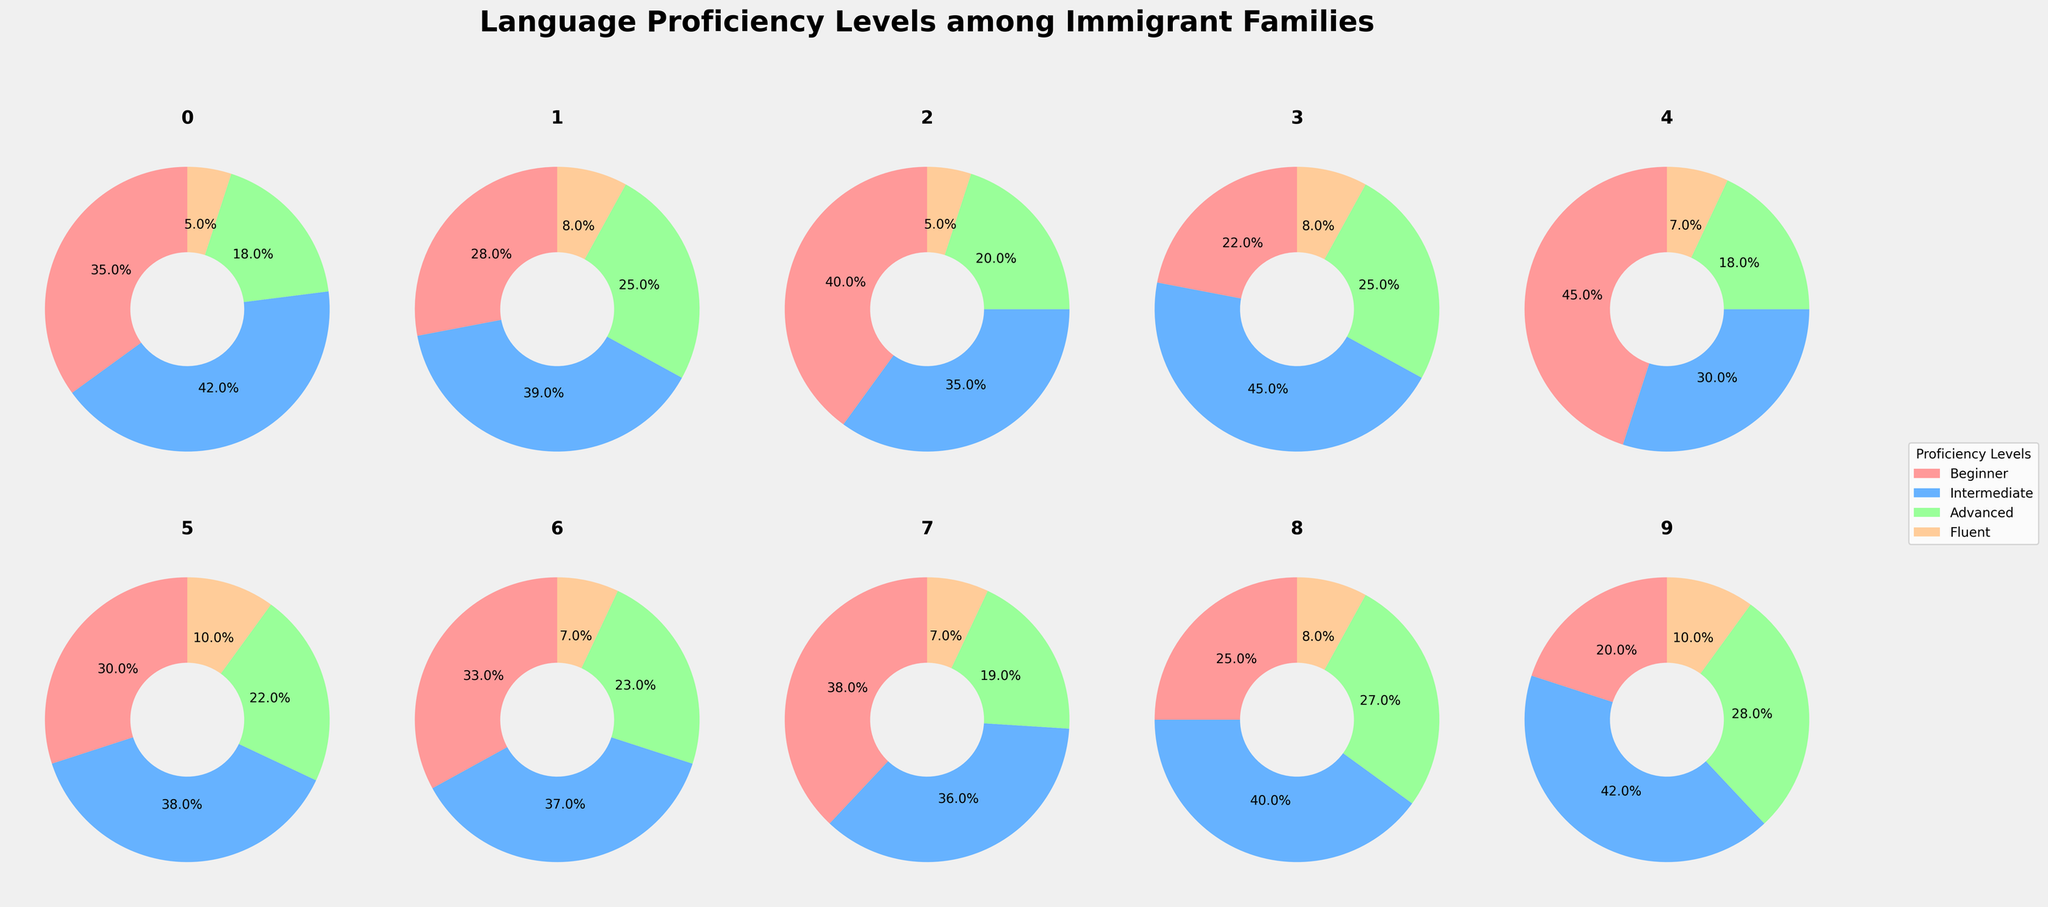Which native language has the highest proportion of Beginner proficiency levels? Looking at the slices labeled 'Beginner' in each pie chart, we can see that the Arabic language has the largest slice for Beginner proficiency.
Answer: Arabic What is the combined percentage of Fluent proficiency for Chinese, Russian, and Vietnamese? Adding the Fluent percentages directly from each language's chart: Chinese (8%) + Russian (8%) + Vietnamese (5%) gives us a total.
Answer: 21% Which language shows a more even distribution across all proficiency levels? By examining the pie charts, Portuguese and Tagalog show relatively balanced distributions across all proficiency levels. However, Portuguese has no overly dominant segment.
Answer: Portuguese How does the number of Intermediate proficiency levels compare between Spanish and Polish? From the pie charts, Spanish has 30% Intermediate, and Polish has 31% Intermediate, so Polish has a marginally higher proportion.
Answer: Polish Which language has the lowest proportion of Fluent speakers? Comparing the 'Fluent' slices of each pie chart, Spanish and Vietnamese both have the smallest slice for Fluent proficiency.
Answer: Spanish and Vietnamese What is the percentage difference in Advanced proficiency between Korean and Tagalog? Korean has 23% Advanced, and Tagalog has 22% Advanced, resulting in a difference of 1%.
Answer: 1% Do any languages have more than 50% combined Intermediate and Advanced proficiency? We need to sum the Intermediate and Advanced sections for each pie chart. Russian (45% + 25%) and Portuguese (40% + 27%) both exceed 50%.
Answer: Russian and Portuguese Which languages have at least 20% each in both Beginner and Intermediate proficiency levels? From the charts, Spanish, Chinese, Vietnamese, Korean, Haitian Creole, and Arabic all demonstrate both Beginner and Intermediate segments of at least 20%.
Answer: Spanish, Chinese, Vietnamese, Korean, Haitian Creole, Arabic Is the proportion of Advanced proficiency higher in Chinese or Arabic? Comparing the Advanced segments, Chinese has 25%, while Arabic has 18%, making Chinese the language with higher Advanced proficiency.
Answer: Chinese Which language has the highest proportion of Intermediate proficiency levels? By checking the Intermediate slices, Russian has the highest at 45%.
Answer: Russian 